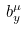Convert formula to latex. <formula><loc_0><loc_0><loc_500><loc_500>b _ { y } ^ { \mu }</formula> 